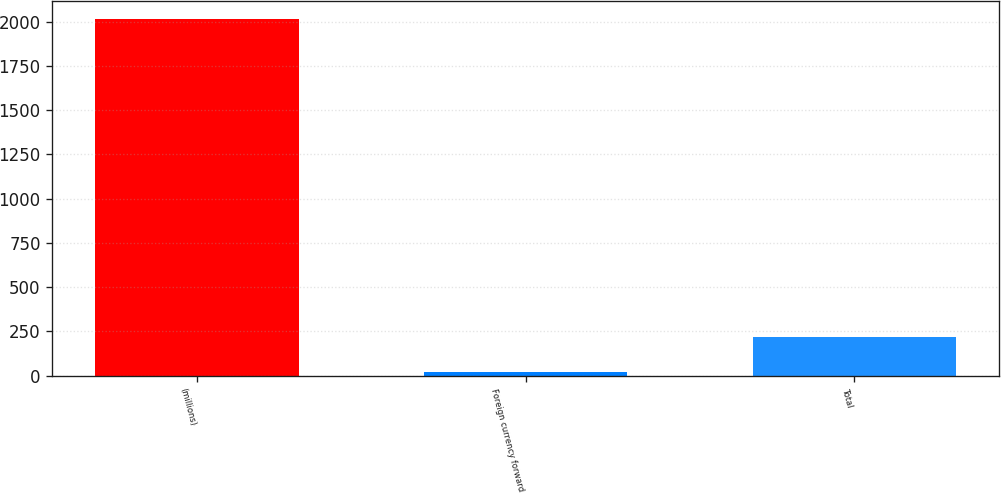Convert chart to OTSL. <chart><loc_0><loc_0><loc_500><loc_500><bar_chart><fcel>(millions)<fcel>Foreign currency forward<fcel>Total<nl><fcel>2014<fcel>17.9<fcel>217.51<nl></chart> 